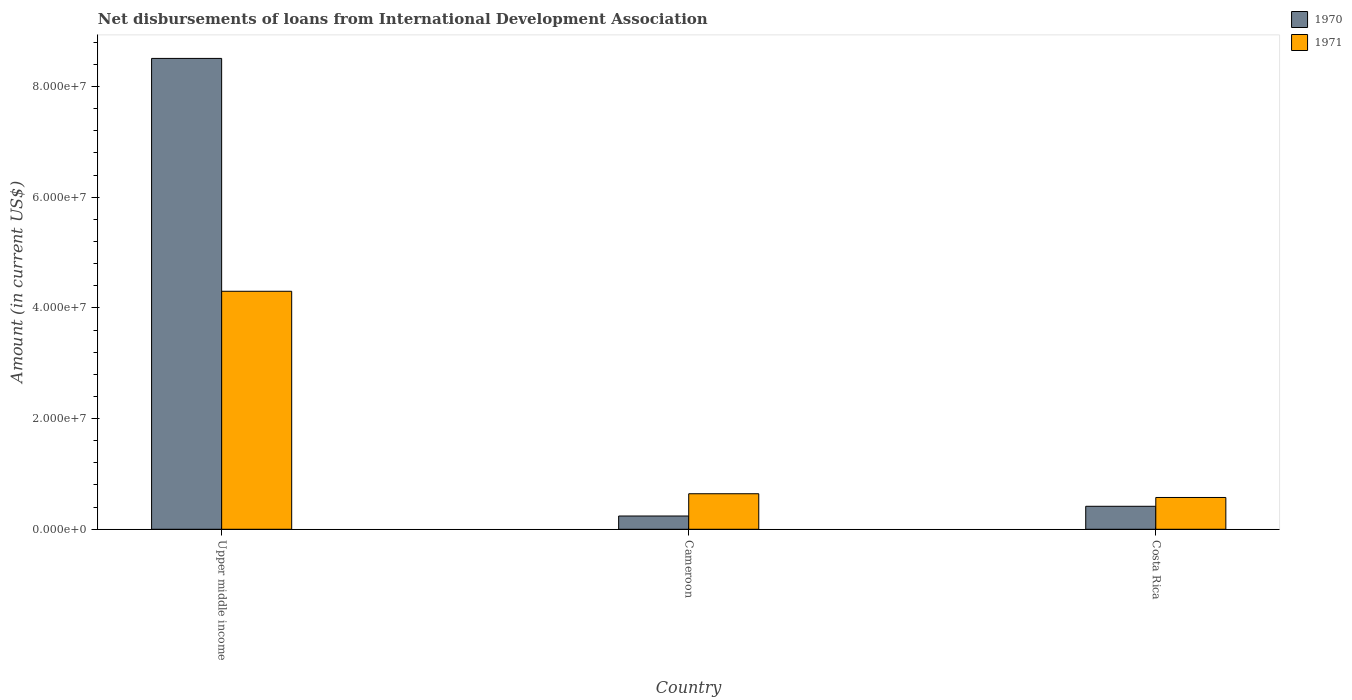How many groups of bars are there?
Offer a very short reply. 3. What is the label of the 2nd group of bars from the left?
Give a very brief answer. Cameroon. What is the amount of loans disbursed in 1971 in Cameroon?
Ensure brevity in your answer.  6.42e+06. Across all countries, what is the maximum amount of loans disbursed in 1971?
Keep it short and to the point. 4.30e+07. Across all countries, what is the minimum amount of loans disbursed in 1971?
Your answer should be very brief. 5.74e+06. In which country was the amount of loans disbursed in 1971 maximum?
Ensure brevity in your answer.  Upper middle income. In which country was the amount of loans disbursed in 1970 minimum?
Ensure brevity in your answer.  Cameroon. What is the total amount of loans disbursed in 1970 in the graph?
Keep it short and to the point. 9.16e+07. What is the difference between the amount of loans disbursed in 1971 in Cameroon and that in Upper middle income?
Keep it short and to the point. -3.66e+07. What is the difference between the amount of loans disbursed in 1970 in Upper middle income and the amount of loans disbursed in 1971 in Costa Rica?
Provide a short and direct response. 7.93e+07. What is the average amount of loans disbursed in 1971 per country?
Keep it short and to the point. 1.84e+07. What is the difference between the amount of loans disbursed of/in 1970 and amount of loans disbursed of/in 1971 in Upper middle income?
Make the answer very short. 4.21e+07. What is the ratio of the amount of loans disbursed in 1970 in Costa Rica to that in Upper middle income?
Offer a very short reply. 0.05. Is the amount of loans disbursed in 1971 in Cameroon less than that in Upper middle income?
Offer a very short reply. Yes. What is the difference between the highest and the second highest amount of loans disbursed in 1971?
Ensure brevity in your answer.  3.66e+07. What is the difference between the highest and the lowest amount of loans disbursed in 1970?
Offer a terse response. 8.27e+07. What does the 2nd bar from the left in Cameroon represents?
Your answer should be compact. 1971. What does the 2nd bar from the right in Cameroon represents?
Provide a short and direct response. 1970. How many bars are there?
Your answer should be very brief. 6. How many countries are there in the graph?
Provide a short and direct response. 3. What is the difference between two consecutive major ticks on the Y-axis?
Keep it short and to the point. 2.00e+07. Does the graph contain any zero values?
Make the answer very short. No. Where does the legend appear in the graph?
Give a very brief answer. Top right. How are the legend labels stacked?
Ensure brevity in your answer.  Vertical. What is the title of the graph?
Your answer should be compact. Net disbursements of loans from International Development Association. What is the label or title of the Y-axis?
Offer a terse response. Amount (in current US$). What is the Amount (in current US$) of 1970 in Upper middle income?
Provide a succinct answer. 8.51e+07. What is the Amount (in current US$) in 1971 in Upper middle income?
Offer a terse response. 4.30e+07. What is the Amount (in current US$) in 1970 in Cameroon?
Give a very brief answer. 2.40e+06. What is the Amount (in current US$) in 1971 in Cameroon?
Provide a short and direct response. 6.42e+06. What is the Amount (in current US$) in 1970 in Costa Rica?
Offer a terse response. 4.15e+06. What is the Amount (in current US$) of 1971 in Costa Rica?
Your answer should be compact. 5.74e+06. Across all countries, what is the maximum Amount (in current US$) of 1970?
Make the answer very short. 8.51e+07. Across all countries, what is the maximum Amount (in current US$) of 1971?
Provide a succinct answer. 4.30e+07. Across all countries, what is the minimum Amount (in current US$) in 1970?
Ensure brevity in your answer.  2.40e+06. Across all countries, what is the minimum Amount (in current US$) in 1971?
Give a very brief answer. 5.74e+06. What is the total Amount (in current US$) in 1970 in the graph?
Give a very brief answer. 9.16e+07. What is the total Amount (in current US$) of 1971 in the graph?
Offer a terse response. 5.52e+07. What is the difference between the Amount (in current US$) in 1970 in Upper middle income and that in Cameroon?
Your answer should be compact. 8.27e+07. What is the difference between the Amount (in current US$) in 1971 in Upper middle income and that in Cameroon?
Keep it short and to the point. 3.66e+07. What is the difference between the Amount (in current US$) of 1970 in Upper middle income and that in Costa Rica?
Your response must be concise. 8.09e+07. What is the difference between the Amount (in current US$) in 1971 in Upper middle income and that in Costa Rica?
Keep it short and to the point. 3.73e+07. What is the difference between the Amount (in current US$) in 1970 in Cameroon and that in Costa Rica?
Keep it short and to the point. -1.76e+06. What is the difference between the Amount (in current US$) of 1971 in Cameroon and that in Costa Rica?
Give a very brief answer. 6.75e+05. What is the difference between the Amount (in current US$) in 1970 in Upper middle income and the Amount (in current US$) in 1971 in Cameroon?
Provide a short and direct response. 7.86e+07. What is the difference between the Amount (in current US$) in 1970 in Upper middle income and the Amount (in current US$) in 1971 in Costa Rica?
Offer a terse response. 7.93e+07. What is the difference between the Amount (in current US$) of 1970 in Cameroon and the Amount (in current US$) of 1971 in Costa Rica?
Your answer should be compact. -3.35e+06. What is the average Amount (in current US$) of 1970 per country?
Give a very brief answer. 3.05e+07. What is the average Amount (in current US$) in 1971 per country?
Provide a succinct answer. 1.84e+07. What is the difference between the Amount (in current US$) in 1970 and Amount (in current US$) in 1971 in Upper middle income?
Keep it short and to the point. 4.21e+07. What is the difference between the Amount (in current US$) of 1970 and Amount (in current US$) of 1971 in Cameroon?
Provide a short and direct response. -4.02e+06. What is the difference between the Amount (in current US$) of 1970 and Amount (in current US$) of 1971 in Costa Rica?
Offer a terse response. -1.59e+06. What is the ratio of the Amount (in current US$) of 1970 in Upper middle income to that in Cameroon?
Your answer should be very brief. 35.5. What is the ratio of the Amount (in current US$) of 1971 in Upper middle income to that in Cameroon?
Make the answer very short. 6.7. What is the ratio of the Amount (in current US$) of 1970 in Upper middle income to that in Costa Rica?
Keep it short and to the point. 20.48. What is the ratio of the Amount (in current US$) in 1971 in Upper middle income to that in Costa Rica?
Offer a very short reply. 7.49. What is the ratio of the Amount (in current US$) of 1970 in Cameroon to that in Costa Rica?
Offer a terse response. 0.58. What is the ratio of the Amount (in current US$) in 1971 in Cameroon to that in Costa Rica?
Give a very brief answer. 1.12. What is the difference between the highest and the second highest Amount (in current US$) in 1970?
Your response must be concise. 8.09e+07. What is the difference between the highest and the second highest Amount (in current US$) in 1971?
Your answer should be very brief. 3.66e+07. What is the difference between the highest and the lowest Amount (in current US$) of 1970?
Your response must be concise. 8.27e+07. What is the difference between the highest and the lowest Amount (in current US$) of 1971?
Keep it short and to the point. 3.73e+07. 